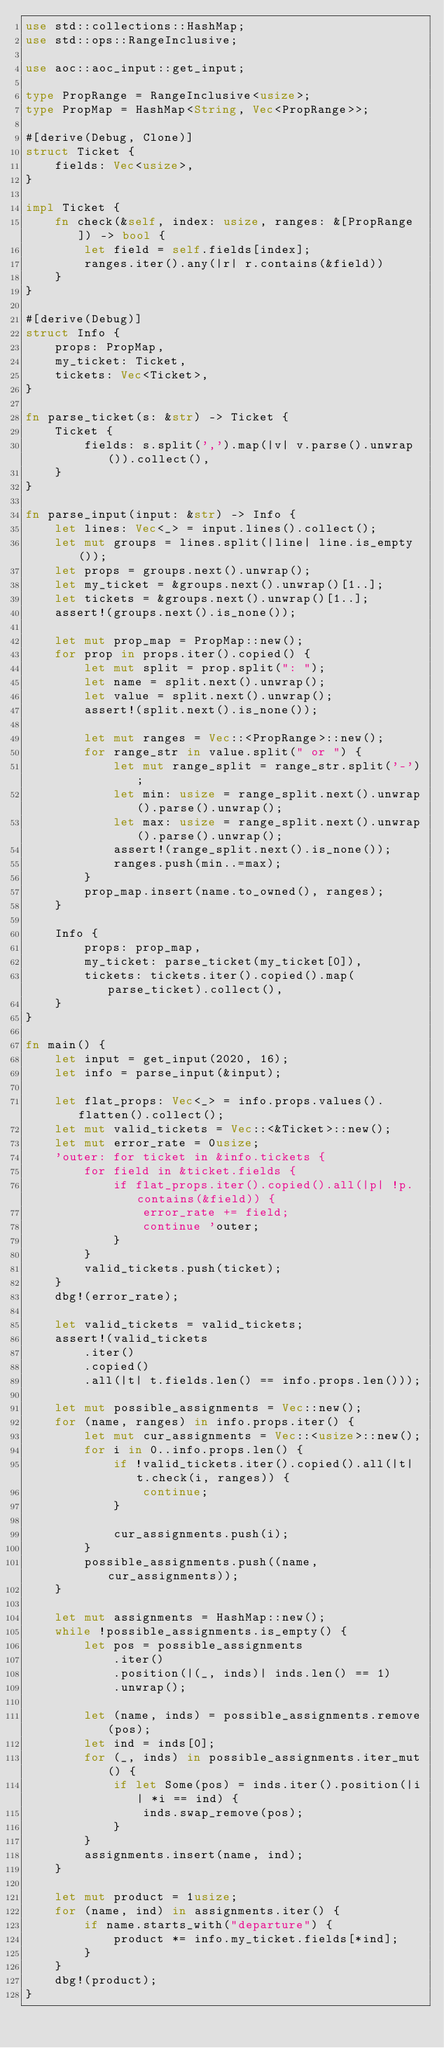<code> <loc_0><loc_0><loc_500><loc_500><_Rust_>use std::collections::HashMap;
use std::ops::RangeInclusive;

use aoc::aoc_input::get_input;

type PropRange = RangeInclusive<usize>;
type PropMap = HashMap<String, Vec<PropRange>>;

#[derive(Debug, Clone)]
struct Ticket {
    fields: Vec<usize>,
}

impl Ticket {
    fn check(&self, index: usize, ranges: &[PropRange]) -> bool {
        let field = self.fields[index];
        ranges.iter().any(|r| r.contains(&field))
    }
}

#[derive(Debug)]
struct Info {
    props: PropMap,
    my_ticket: Ticket,
    tickets: Vec<Ticket>,
}

fn parse_ticket(s: &str) -> Ticket {
    Ticket {
        fields: s.split(',').map(|v| v.parse().unwrap()).collect(),
    }
}

fn parse_input(input: &str) -> Info {
    let lines: Vec<_> = input.lines().collect();
    let mut groups = lines.split(|line| line.is_empty());
    let props = groups.next().unwrap();
    let my_ticket = &groups.next().unwrap()[1..];
    let tickets = &groups.next().unwrap()[1..];
    assert!(groups.next().is_none());

    let mut prop_map = PropMap::new();
    for prop in props.iter().copied() {
        let mut split = prop.split(": ");
        let name = split.next().unwrap();
        let value = split.next().unwrap();
        assert!(split.next().is_none());

        let mut ranges = Vec::<PropRange>::new();
        for range_str in value.split(" or ") {
            let mut range_split = range_str.split('-');
            let min: usize = range_split.next().unwrap().parse().unwrap();
            let max: usize = range_split.next().unwrap().parse().unwrap();
            assert!(range_split.next().is_none());
            ranges.push(min..=max);
        }
        prop_map.insert(name.to_owned(), ranges);
    }

    Info {
        props: prop_map,
        my_ticket: parse_ticket(my_ticket[0]),
        tickets: tickets.iter().copied().map(parse_ticket).collect(),
    }
}

fn main() {
    let input = get_input(2020, 16);
    let info = parse_input(&input);

    let flat_props: Vec<_> = info.props.values().flatten().collect();
    let mut valid_tickets = Vec::<&Ticket>::new();
    let mut error_rate = 0usize;
    'outer: for ticket in &info.tickets {
        for field in &ticket.fields {
            if flat_props.iter().copied().all(|p| !p.contains(&field)) {
                error_rate += field;
                continue 'outer;
            }
        }
        valid_tickets.push(ticket);
    }
    dbg!(error_rate);

    let valid_tickets = valid_tickets;
    assert!(valid_tickets
        .iter()
        .copied()
        .all(|t| t.fields.len() == info.props.len()));

    let mut possible_assignments = Vec::new();
    for (name, ranges) in info.props.iter() {
        let mut cur_assignments = Vec::<usize>::new();
        for i in 0..info.props.len() {
            if !valid_tickets.iter().copied().all(|t| t.check(i, ranges)) {
                continue;
            }

            cur_assignments.push(i);
        }
        possible_assignments.push((name, cur_assignments));
    }

    let mut assignments = HashMap::new();
    while !possible_assignments.is_empty() {
        let pos = possible_assignments
            .iter()
            .position(|(_, inds)| inds.len() == 1)
            .unwrap();

        let (name, inds) = possible_assignments.remove(pos);
        let ind = inds[0];
        for (_, inds) in possible_assignments.iter_mut() {
            if let Some(pos) = inds.iter().position(|i| *i == ind) {
                inds.swap_remove(pos);
            }
        }
        assignments.insert(name, ind);
    }

    let mut product = 1usize;
    for (name, ind) in assignments.iter() {
        if name.starts_with("departure") {
            product *= info.my_ticket.fields[*ind];
        }
    }
    dbg!(product);
}
</code> 